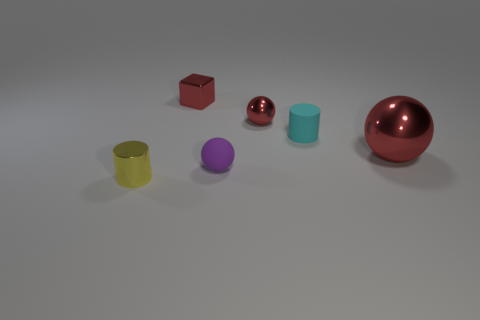There is a big sphere that is the same color as the small metal cube; what is its material?
Your response must be concise. Metal. Is the shape of the large red metallic object the same as the small matte thing that is in front of the matte cylinder?
Ensure brevity in your answer.  Yes. Are there any small spheres of the same color as the matte cylinder?
Provide a succinct answer. No. What number of blocks are tiny shiny objects or metallic things?
Provide a succinct answer. 1. Are there any tiny yellow metal objects of the same shape as the large thing?
Provide a short and direct response. No. What number of other objects are the same color as the small metal cylinder?
Provide a succinct answer. 0. Are there fewer shiny things that are on the left side of the tiny metallic ball than red shiny spheres?
Ensure brevity in your answer.  No. How many blue metallic objects are there?
Ensure brevity in your answer.  0. How many tiny cyan cylinders have the same material as the yellow cylinder?
Ensure brevity in your answer.  0. What number of objects are red balls in front of the tiny red sphere or tiny objects?
Provide a short and direct response. 6. 